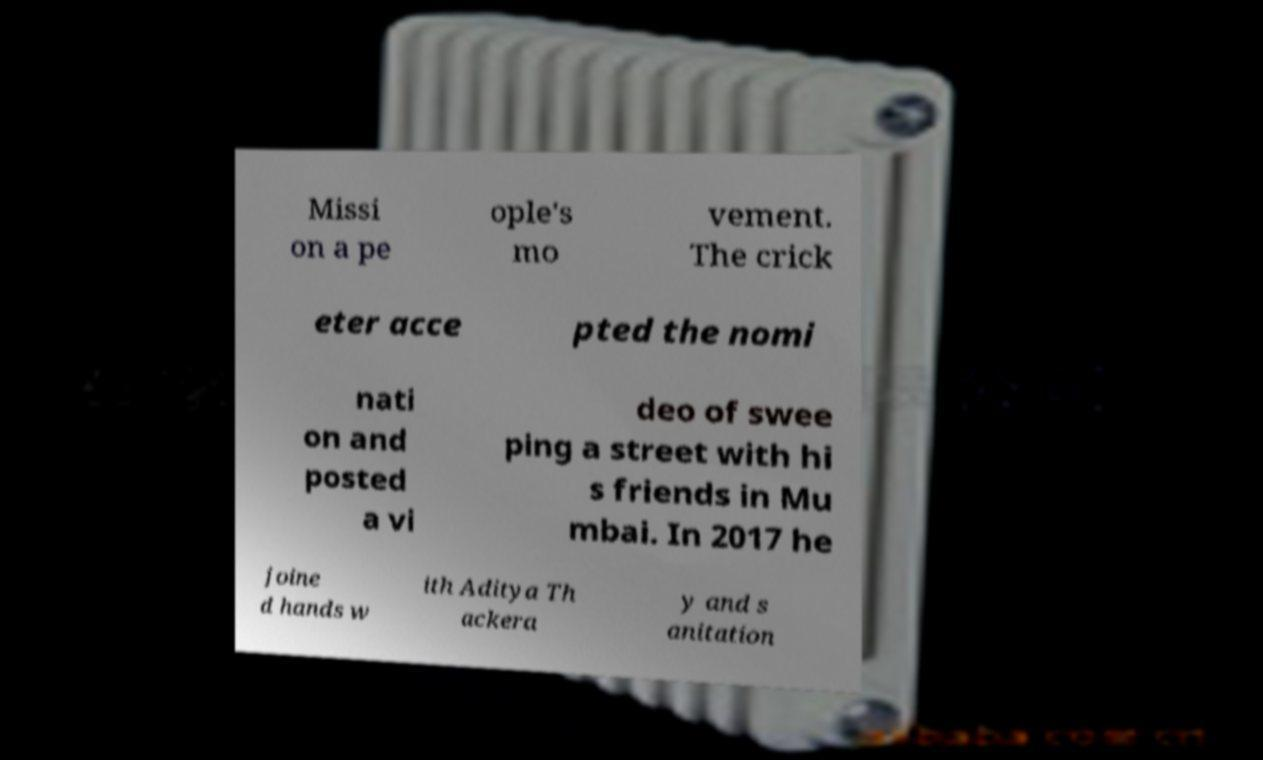Can you read and provide the text displayed in the image?This photo seems to have some interesting text. Can you extract and type it out for me? Missi on a pe ople's mo vement. The crick eter acce pted the nomi nati on and posted a vi deo of swee ping a street with hi s friends in Mu mbai. In 2017 he joine d hands w ith Aditya Th ackera y and s anitation 